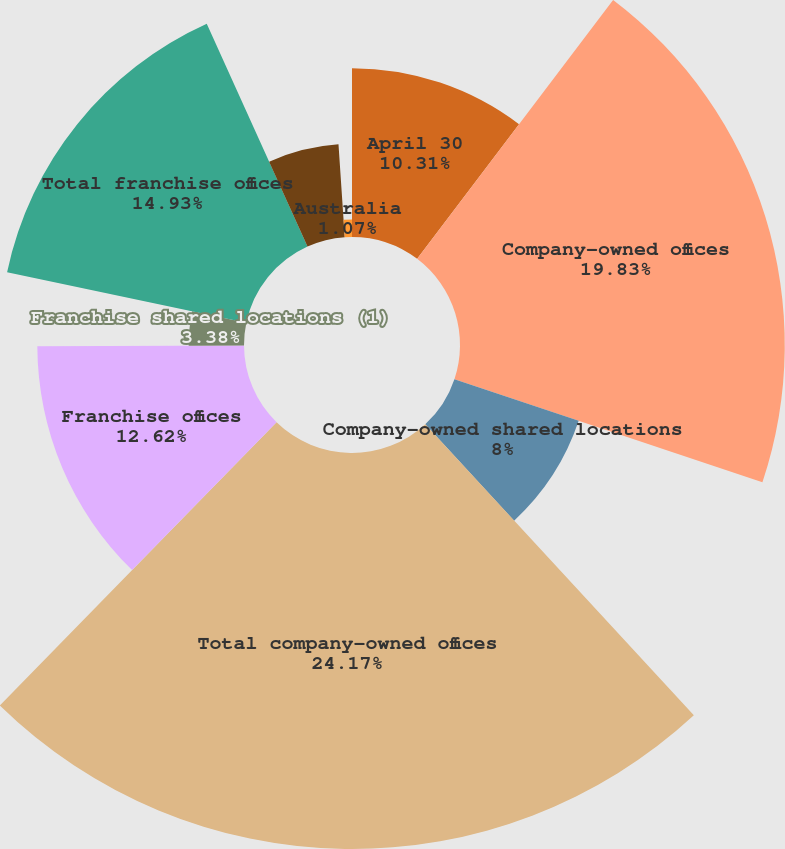Convert chart to OTSL. <chart><loc_0><loc_0><loc_500><loc_500><pie_chart><fcel>April 30<fcel>Company-owned offices<fcel>Company-owned shared locations<fcel>Total company-owned offices<fcel>Franchise offices<fcel>Franchise shared locations (1)<fcel>Total franchise offices<fcel>Canada<fcel>Australia<nl><fcel>10.31%<fcel>19.83%<fcel>8.0%<fcel>24.18%<fcel>12.62%<fcel>3.38%<fcel>14.93%<fcel>5.69%<fcel>1.07%<nl></chart> 